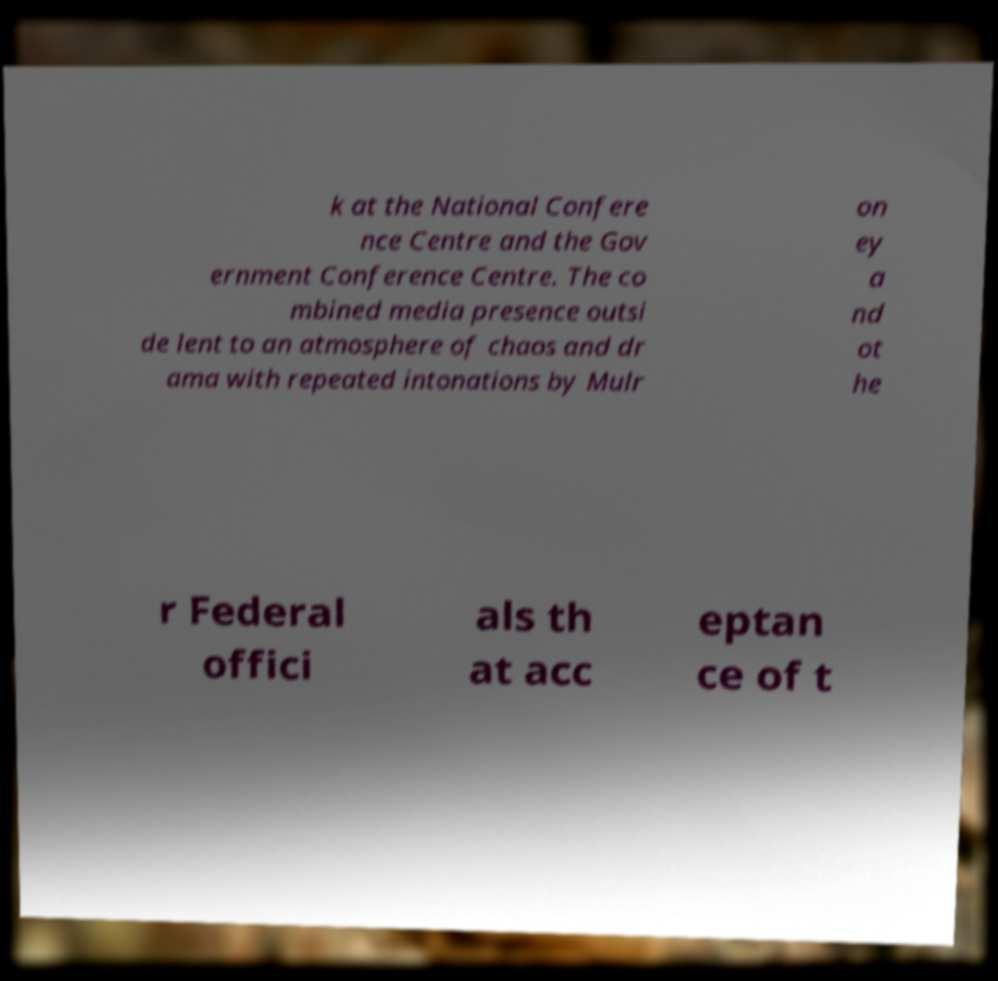What messages or text are displayed in this image? I need them in a readable, typed format. k at the National Confere nce Centre and the Gov ernment Conference Centre. The co mbined media presence outsi de lent to an atmosphere of chaos and dr ama with repeated intonations by Mulr on ey a nd ot he r Federal offici als th at acc eptan ce of t 